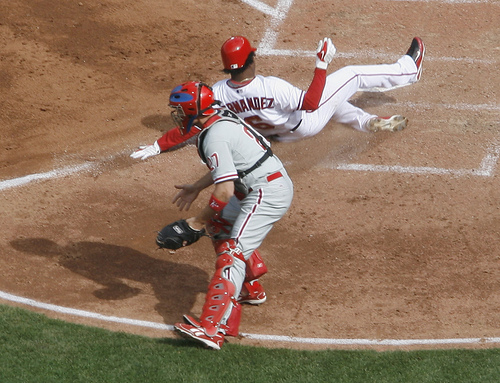Please identify all text content in this image. RNANDEZ 6 7 